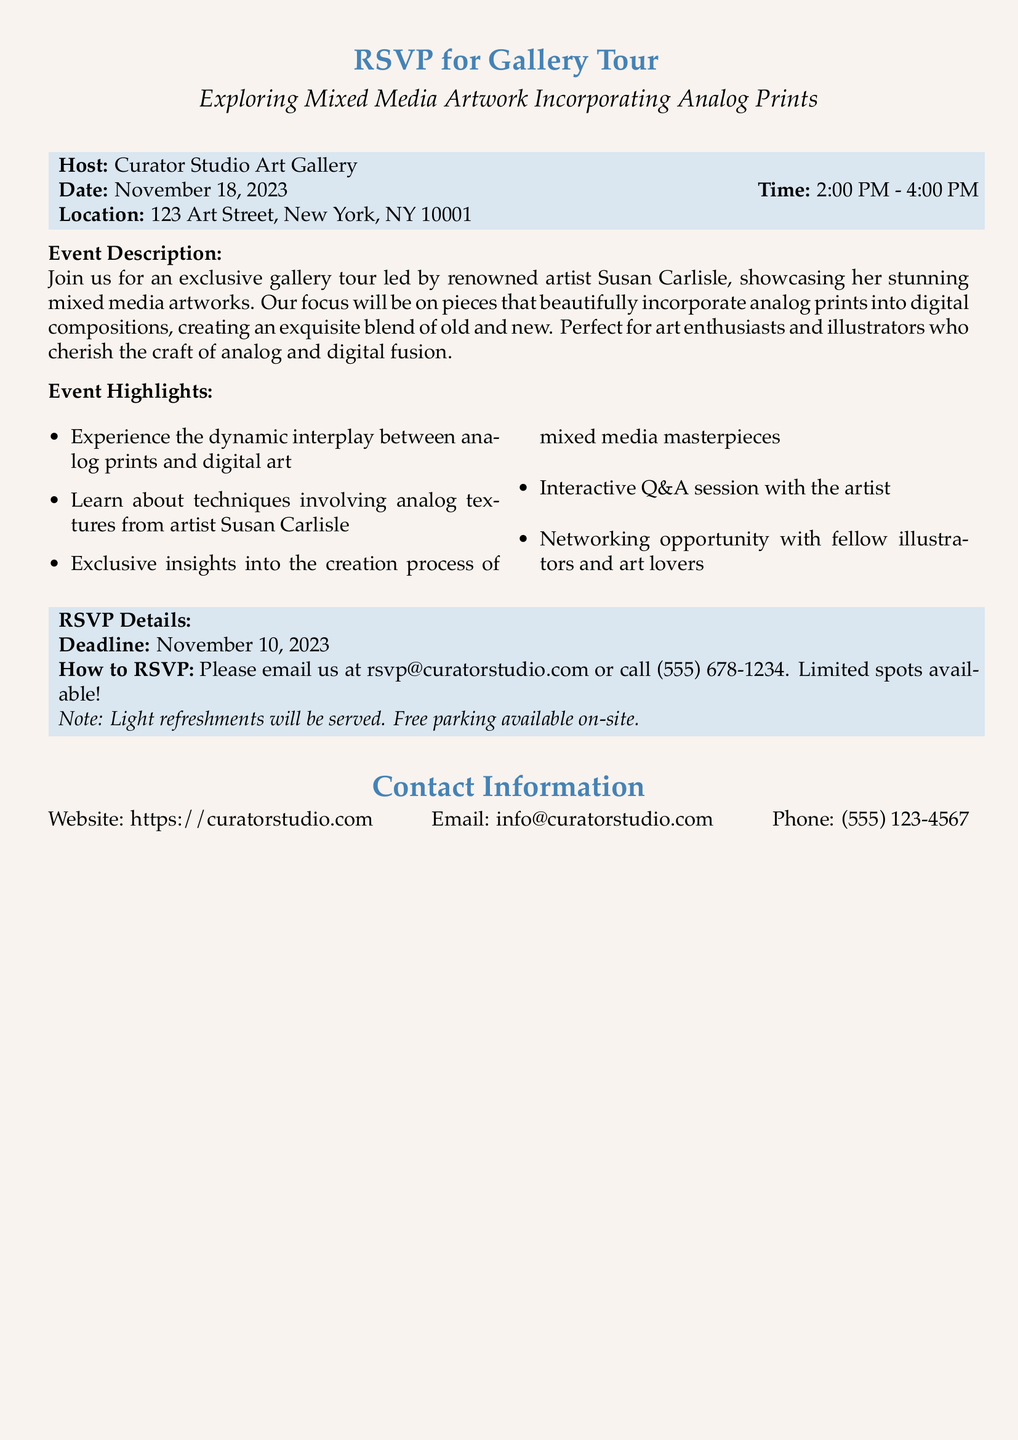What is the date of the gallery tour? The date is specified in the RSVP details as November 18, 2023.
Answer: November 18, 2023 Who is the host of the event? The host is mentioned at the beginning of the document under the host section.
Answer: Curator Studio Art Gallery What time will the event take place? The time is stated as 2:00 PM - 4:00 PM in the RSVP information.
Answer: 2:00 PM - 4:00 PM What is the RSVP email address? The RSVP email address is provided in the RSVP details section.
Answer: rsvp@curatorstudio.com What type of refreshments will be served? The document states that light refreshments will be served during the event.
Answer: Light refreshments What is the main focus of the gallery tour? The focus is explained in the event description section regarding the incorporation of analog prints into digital compositions.
Answer: Mixed media artworks incorporating analog prints What opportunity will attendees have with Susan Carlisle? The document notes an interactive Q&A session with the artist as part of the event highlights.
Answer: Interactive Q&A session When is the RSVP deadline? The RSVP deadline is explicitly mentioned in the RSVP details section as November 10, 2023.
Answer: November 10, 2023 What is one of the highlights of the event? The event highlights contain various points; one of them is learning about techniques from the artist.
Answer: Learn about techniques involving analog textures 